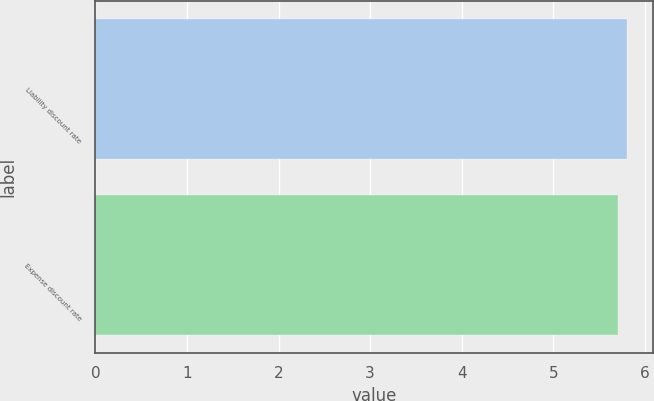Convert chart. <chart><loc_0><loc_0><loc_500><loc_500><bar_chart><fcel>Liability discount rate<fcel>Expense discount rate<nl><fcel>5.8<fcel>5.7<nl></chart> 